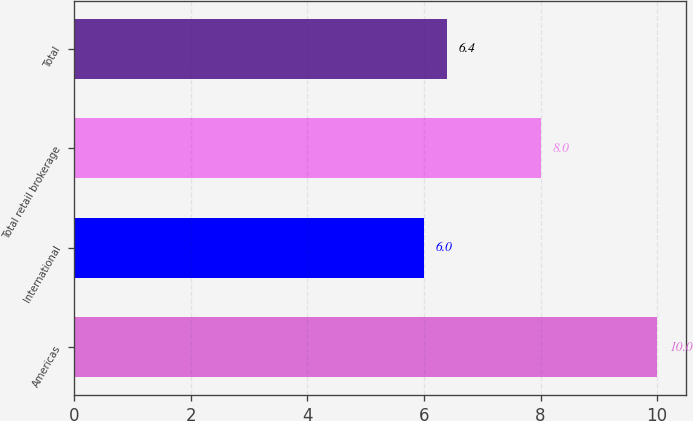<chart> <loc_0><loc_0><loc_500><loc_500><bar_chart><fcel>Americas<fcel>International<fcel>Total retail brokerage<fcel>Total<nl><fcel>10<fcel>6<fcel>8<fcel>6.4<nl></chart> 